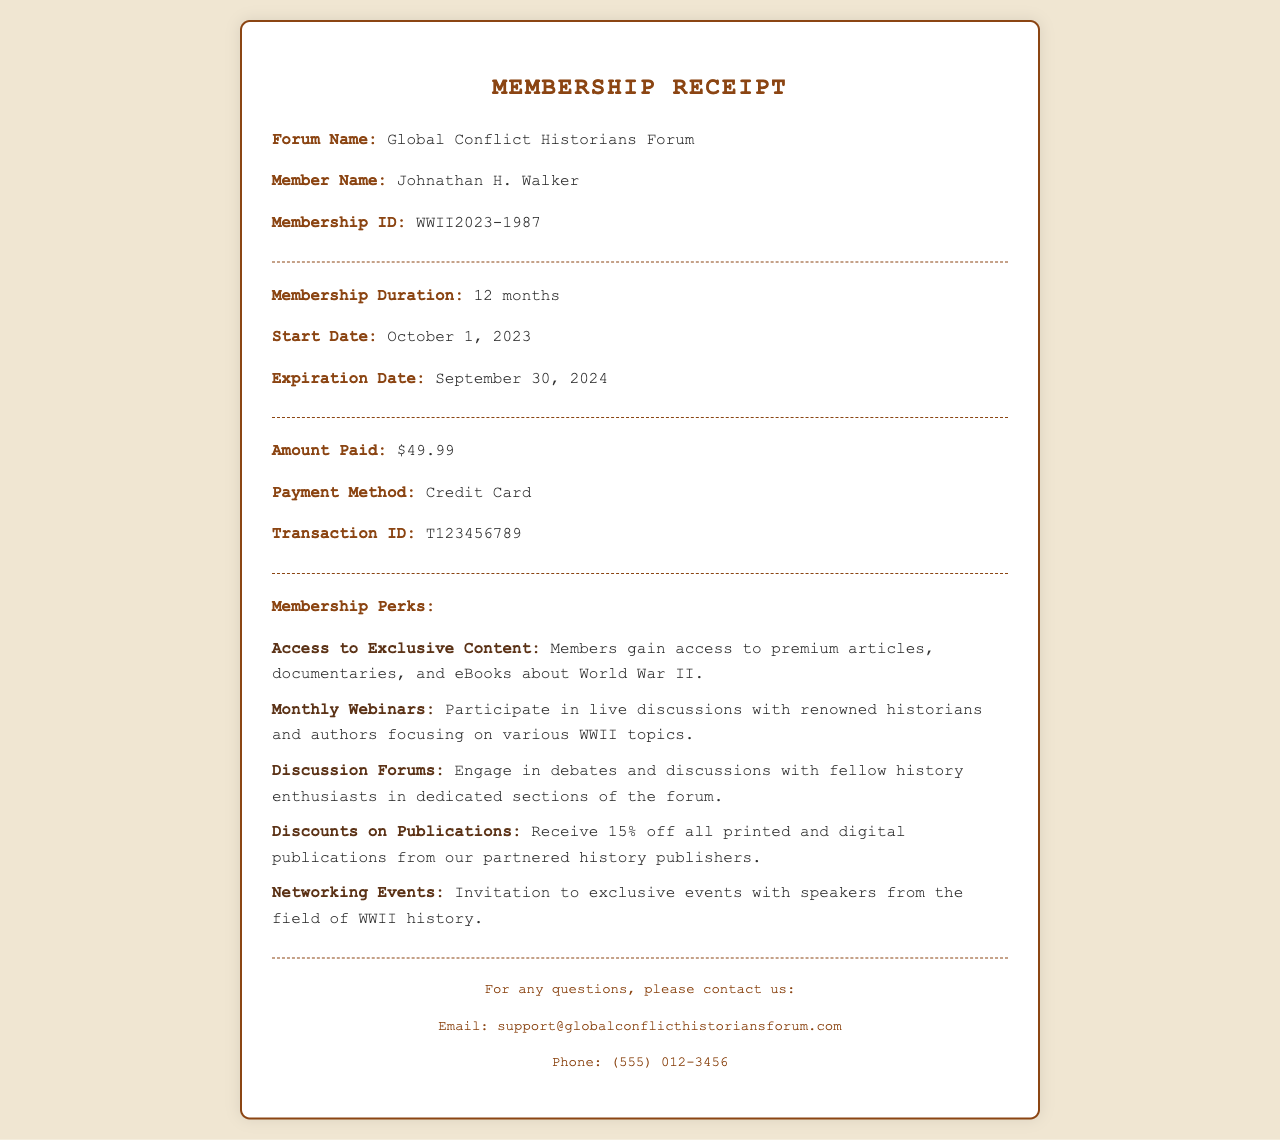What is the forum name? The forum name is clearly indicated in the receipt under the first section.
Answer: Global Conflict Historians Forum Who is the member? The member's name is provided right below the forum name in the membership details.
Answer: Johnathan H. Walker What is the membership ID? The membership ID is specified in the receipt details as part of the member's identification.
Answer: WWII2023-1987 What is the membership duration? The duration is mentioned explicitly in the membership details section of the receipt.
Answer: 12 months What is the amount paid? The amount paid is stated in the payment information section of the document.
Answer: $49.99 What date does the membership expire? The expiration date is provided in the membership duration section.
Answer: September 30, 2024 What is one of the membership perks? The membership perks are listed in the perks section, providing several benefits.
Answer: Access to Exclusive Content How often are the webinars held? The information about the webinars can be deduced from the monthly frequency mentioned.
Answer: Monthly What payment method was used? This detail is found in the payment information section of the receipt.
Answer: Credit Card 